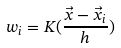Convert formula to latex. <formula><loc_0><loc_0><loc_500><loc_500>w _ { i } = K ( \frac { \vec { x } - \vec { x } _ { i } } { h } )</formula> 